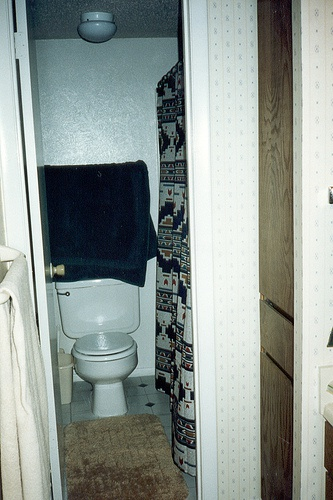Describe the objects in this image and their specific colors. I can see a toilet in darkgray, lightblue, and gray tones in this image. 